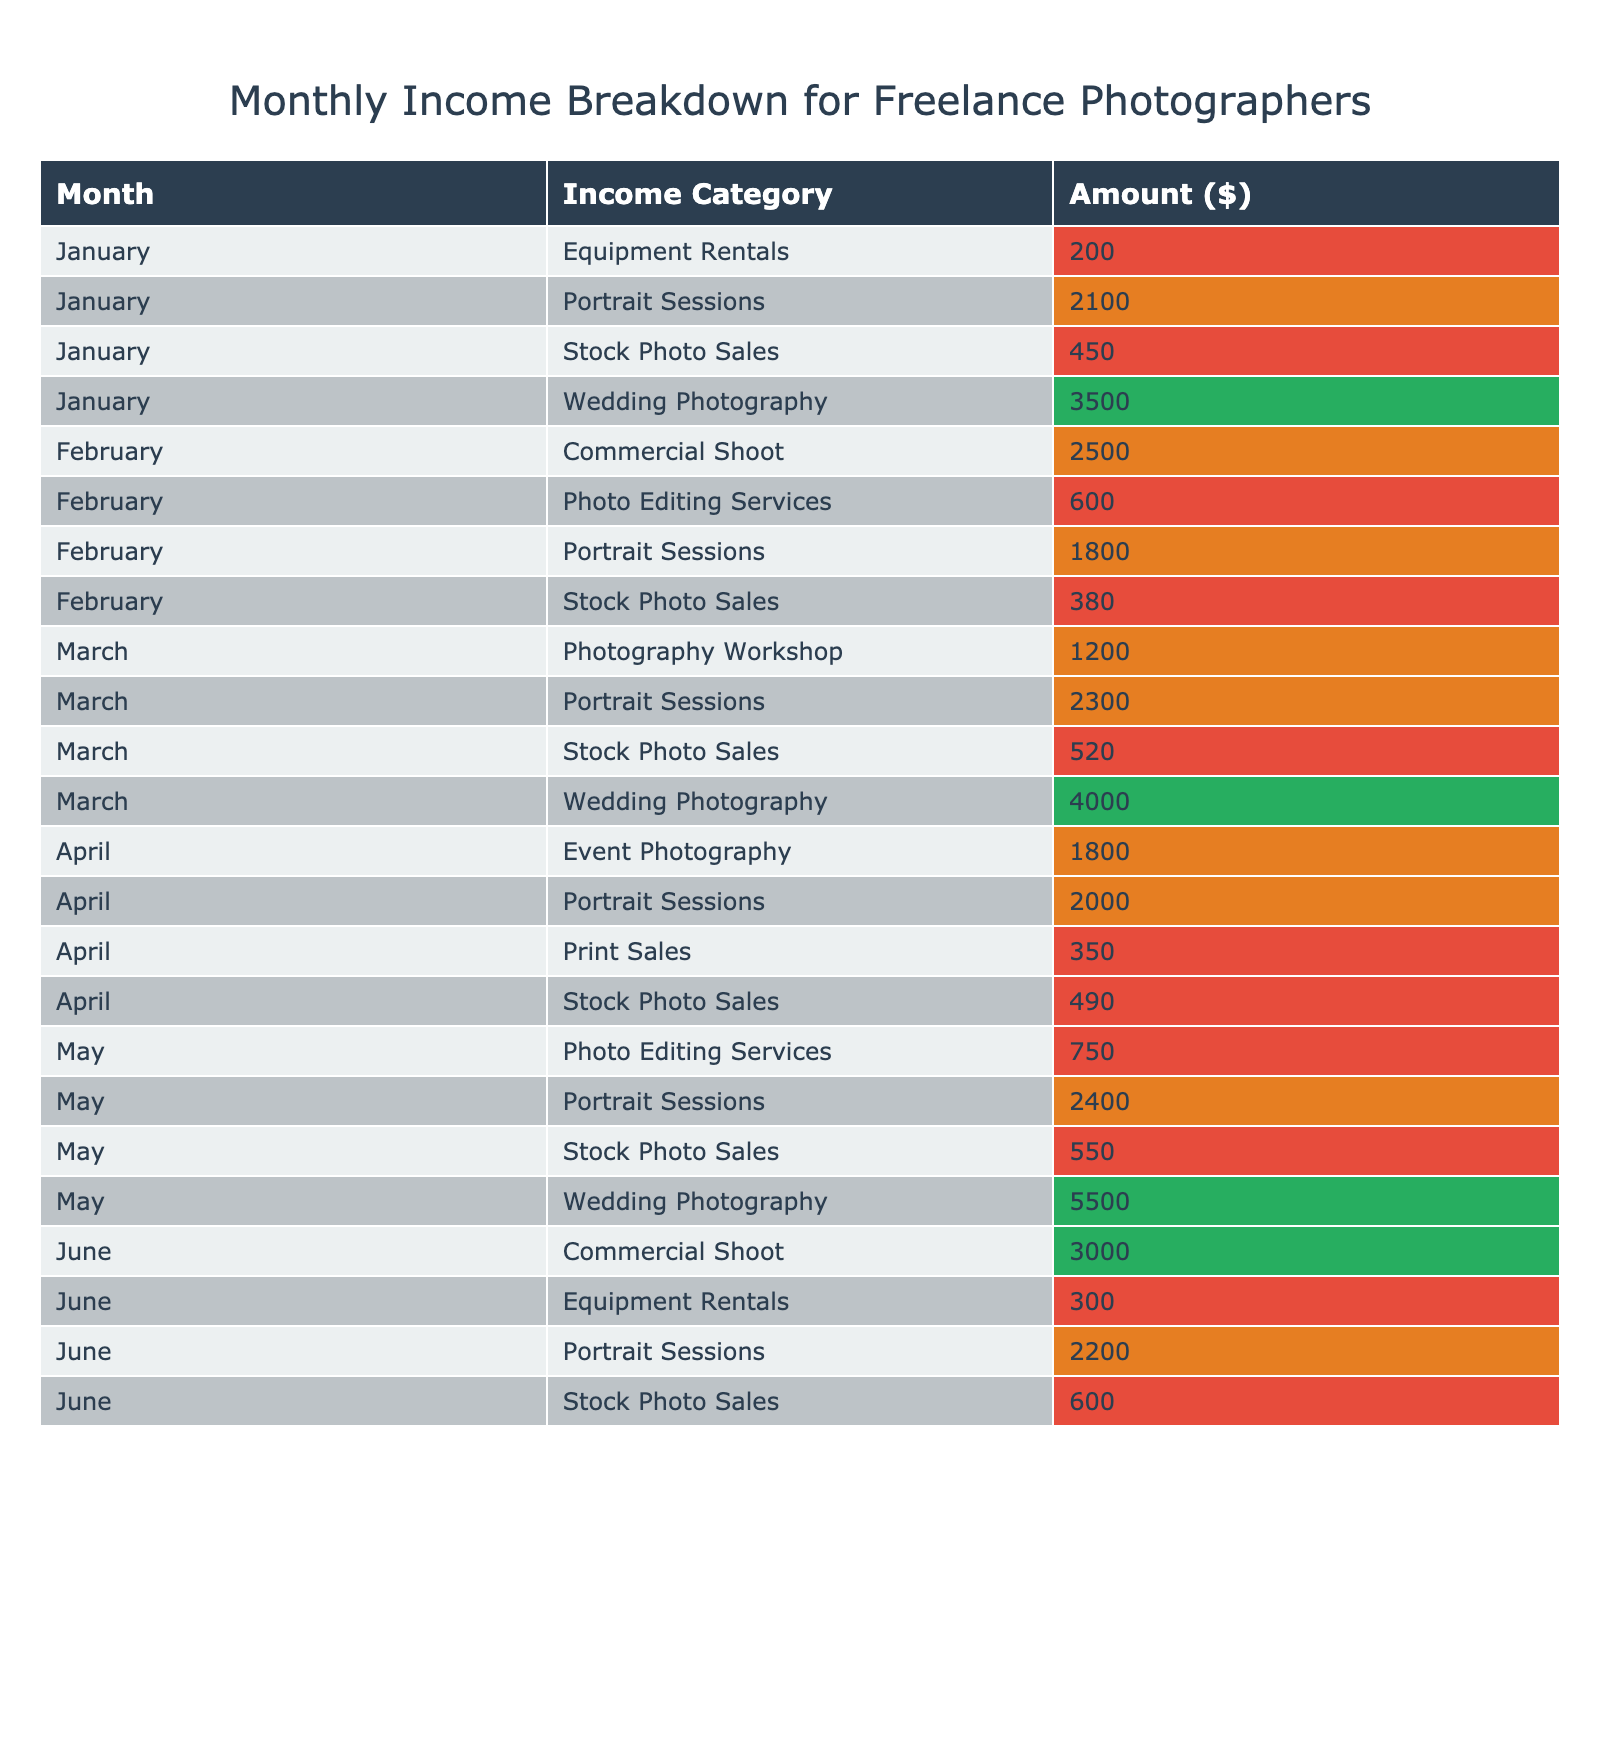What was the total income from Wedding Photography in January? In January, the only income from Wedding Photography is $3500. Thus, the total income from this category in January is simply that amount.
Answer: 3500 Which month had the lowest total income from Stock Photo Sales? To find the month with the lowest total income from Stock Photo Sales, we look at the amounts for each month: January ($450), February ($380), March ($520), April ($490), May ($550), June ($600). The lowest is February with $380.
Answer: February How much income was generated from Portrait Sessions in March? In March, the amount earned from Portrait Sessions is $2300, as stated directly in the table.
Answer: 2300 What is the combined income from Event Photography and Photo Editing Services in April? In April, the income from Event Photography is $1800 and from Photo Editing Services is $0 (since there is none recorded). The combined income is $1800 + $0 = $1800.
Answer: 1800 Which month had the highest total income and what was the amount? To determine the highest total income month, we aggregate the amounts by month: January ($3500 + $2100 + $450 + $200 = $6750), February ($2500 + $1800 + $380 + $600 = $5280), March ($4000 + $2300 + $520 + $1200 = $7020), April ($2000 + $1800 + $490 + $350 = $4640), May ($5500 + $2400 + $550 + $750 = $9200), June ($2200 + $3000 + $600 + $300 = $6100). May has the highest total income of $9200.
Answer: May, 9200 Did any month generate income from Equipment Rentals? Equipment Rentals are recorded in January ($200) and June ($300). Therefore, yes, there are months with income from Equipment Rentals.
Answer: Yes What is the average income from Stock Photo Sales over the six months? Summing the Stock Photo Sales amounts over the six months gives $450 + $380 + $520 + $490 + $550 + $600 = $2990. There are six months, so the average is $2990 / 6 = $498.33, which can be rounded to about $498.
Answer: 498 What is the difference in income from Portrait Sessions between February and May? In February, income from Portrait Sessions is $1800 and in May it is $2400. So, the difference is $2400 - $1800 = $600.
Answer: 600 How many different income categories were there in May? In May, the income categories are Wedding Photography, Portrait Sessions, Stock Photo Sales, and Photo Editing Services, totaling four different categories.
Answer: 4 Was there a month with no income from Commercial Shoot? The only months with no income from Commercial Shoot are January and April. Thus, yes, there were months with no income from this category.
Answer: Yes What was the total income over all months from all income categories? Summing the income from all categories across all months gives: $6750 (January) + $5280 (February) + $7020 (March) + $4640 (April) + $9200 (May) + $6100 (June) = $41090.
Answer: 41090 